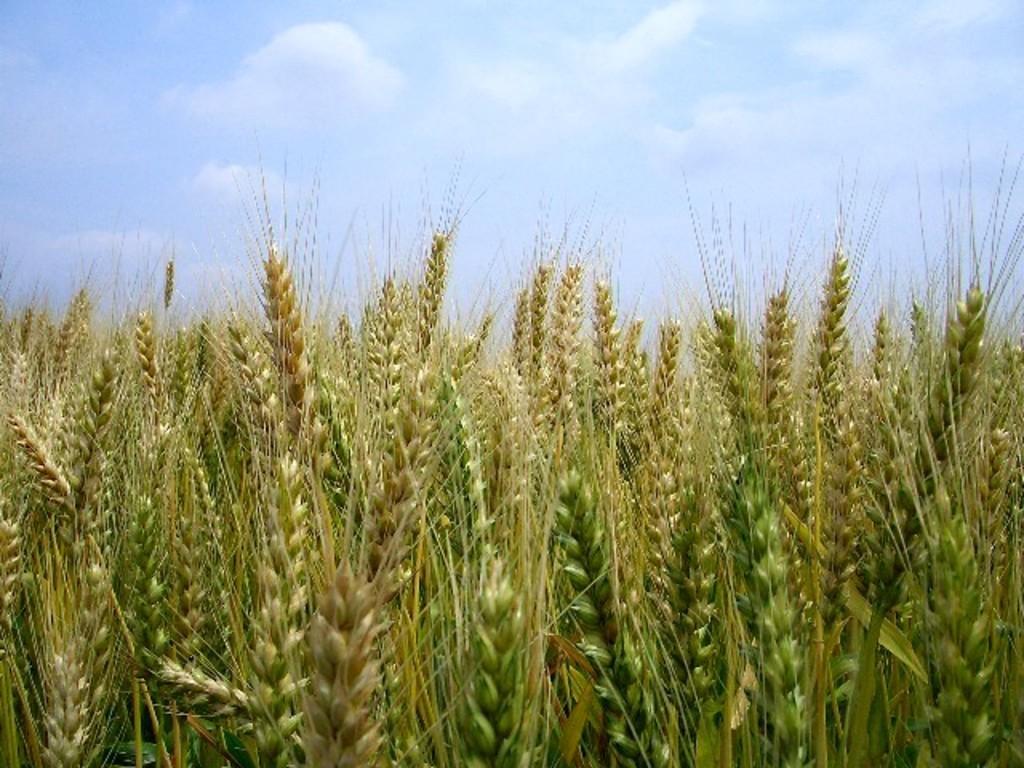Describe this image in one or two sentences. In this picture I can see wheat germs. I can see clouds in the sky. 